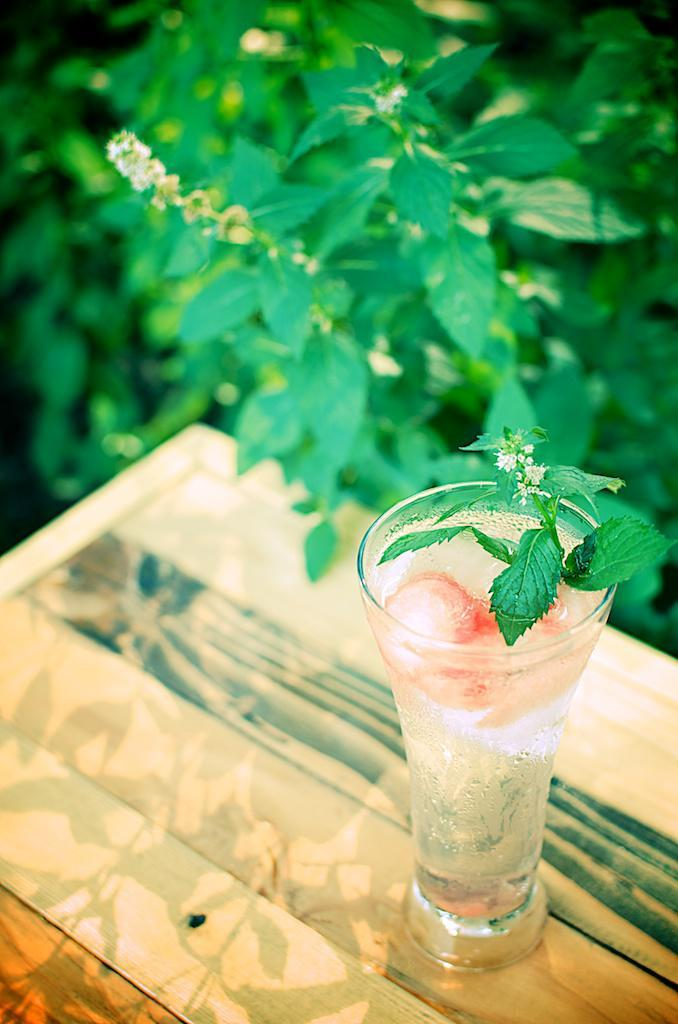What is inside the glass that is visible in the image? There is a drink in the glass that is visible in the image. What is placed on top of the glass? Leaves are placed on top of the glass. What type of surface is the glass placed on? The glass is placed on a wooden surface. What type of vegetation can be seen in the background of the image? Green color plants are visible in the background of the image. What type of industry is depicted in the image? There is no industry depicted in the image; it features a glass with a drink, leaves on top, and a wooden surface. Who is the porter in the image? There is no porter present in the image. 